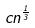Convert formula to latex. <formula><loc_0><loc_0><loc_500><loc_500>c n ^ { \frac { 1 } { 3 } }</formula> 